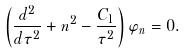<formula> <loc_0><loc_0><loc_500><loc_500>\left ( { \frac { d ^ { 2 } } { d \tau ^ { 2 } } } + n ^ { 2 } - { \frac { C _ { 1 } } { \tau ^ { 2 } } } \right ) \varphi _ { n } = 0 .</formula> 